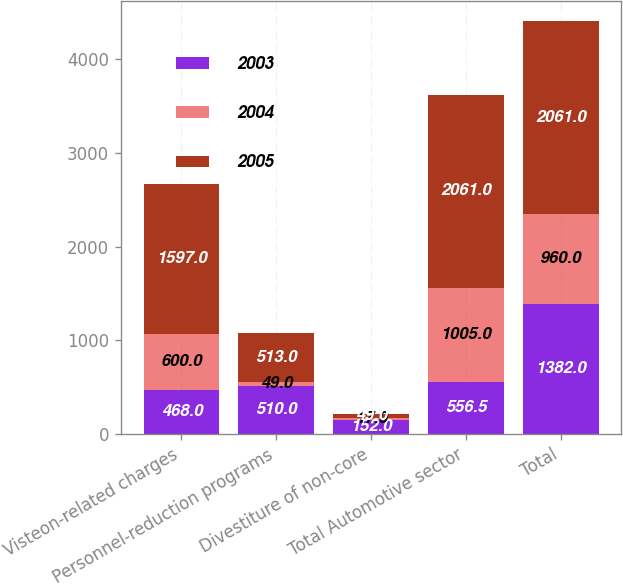Convert chart. <chart><loc_0><loc_0><loc_500><loc_500><stacked_bar_chart><ecel><fcel>Visteon-related charges<fcel>Personnel-reduction programs<fcel>Divestiture of non-core<fcel>Total Automotive sector<fcel>Total<nl><fcel>2003<fcel>468<fcel>510<fcel>152<fcel>556.5<fcel>1382<nl><fcel>2004<fcel>600<fcel>49<fcel>17<fcel>1005<fcel>960<nl><fcel>2005<fcel>1597<fcel>513<fcel>49<fcel>2061<fcel>2061<nl></chart> 